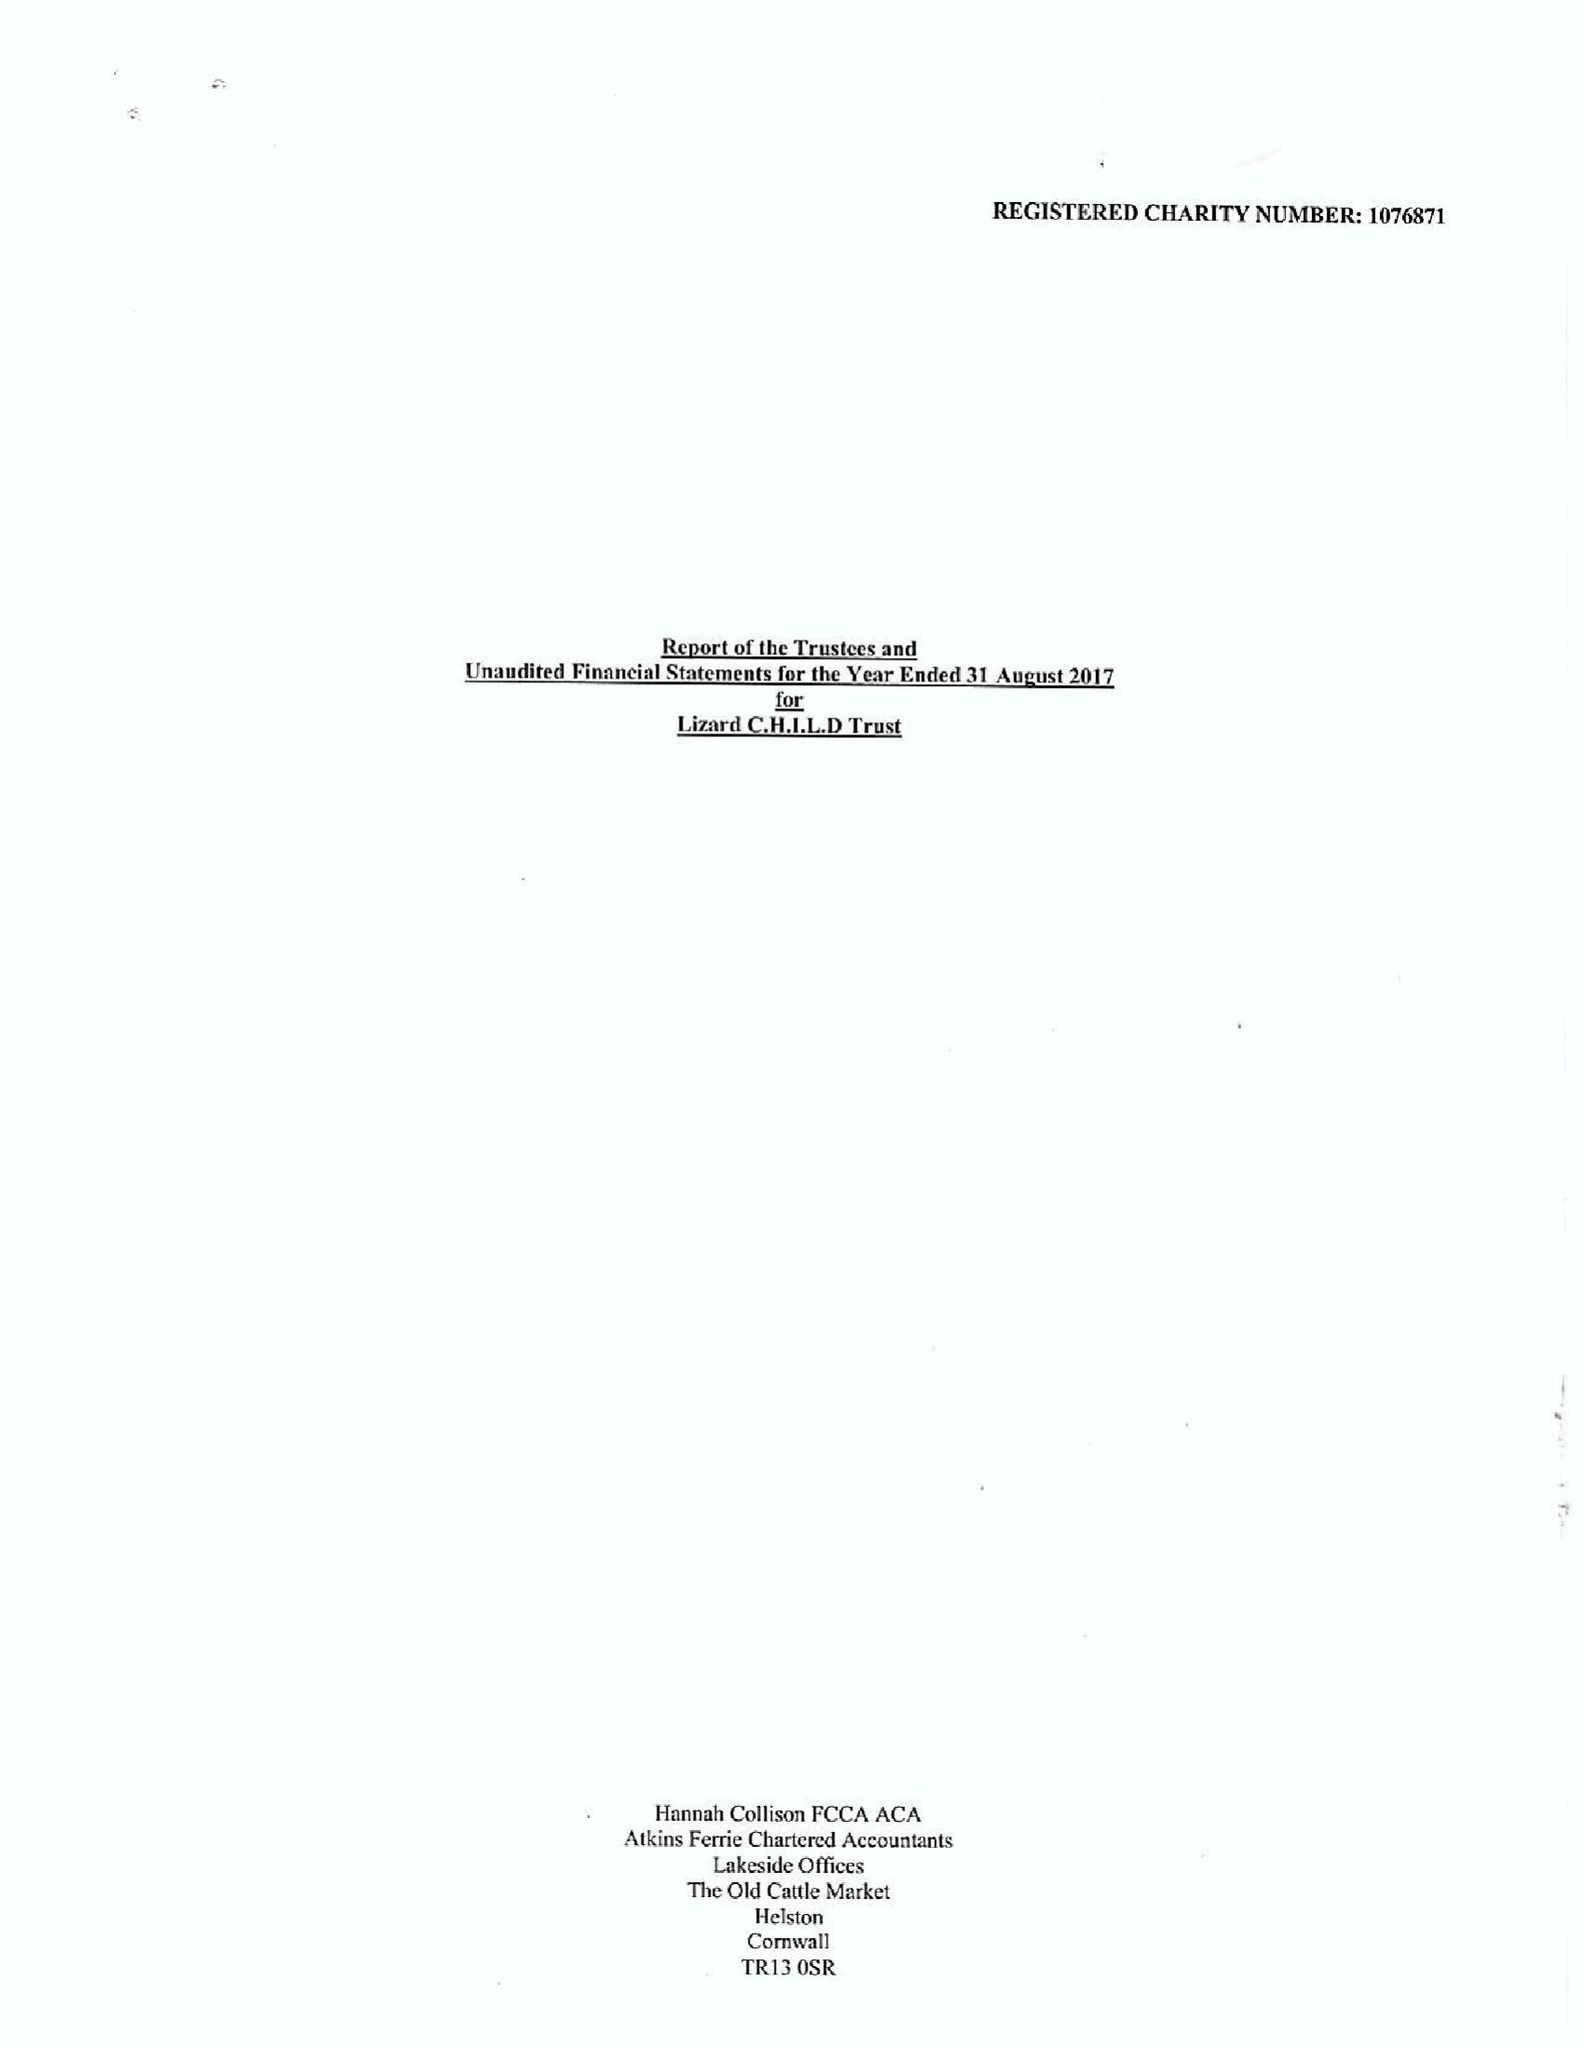What is the value for the spending_annually_in_british_pounds?
Answer the question using a single word or phrase. 264060.00 